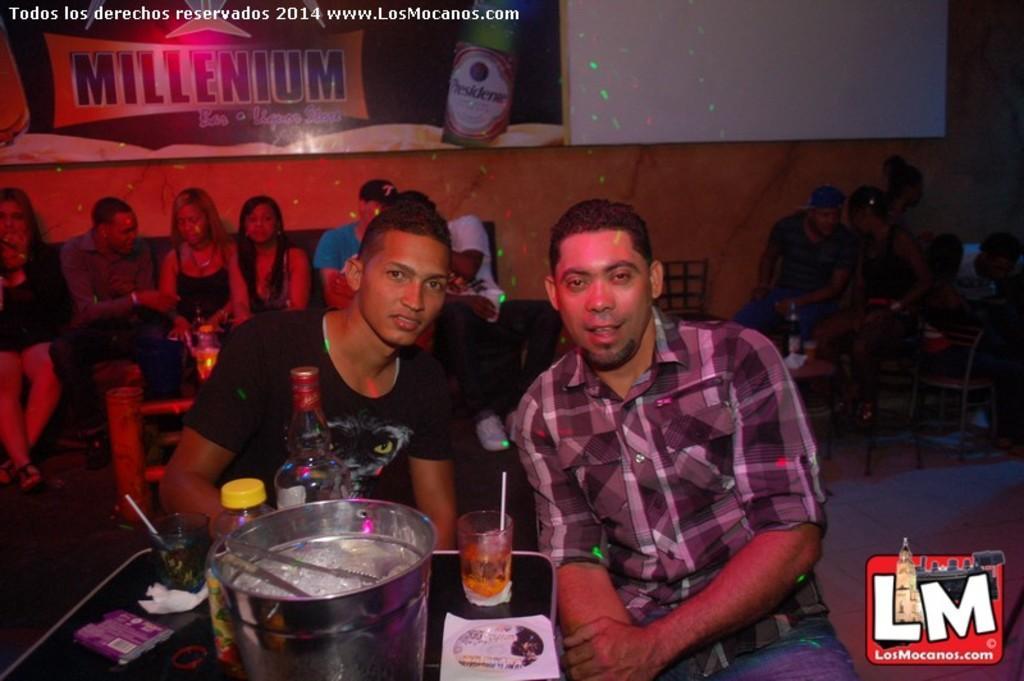How would you summarize this image in a sentence or two? In this picture there are group of people sitting. In the foreground there are glasses and bottles and objects on the table. At the back there are objects on the table and there are chairs and there are boards on the wall and there is text and there is a picture of a bottle on the board. At the top left there is text. At the bottom there is a floor. At the bottom right there is text. 